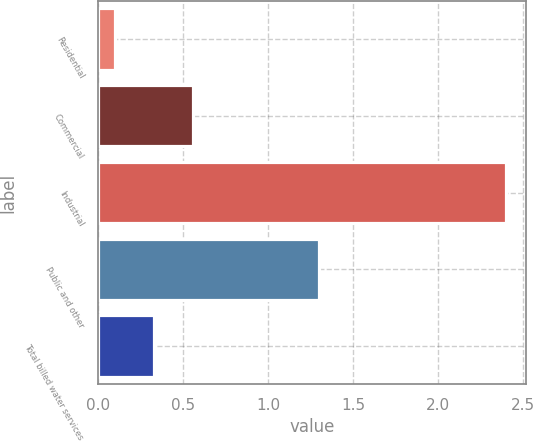<chart> <loc_0><loc_0><loc_500><loc_500><bar_chart><fcel>Residential<fcel>Commercial<fcel>Industrial<fcel>Public and other<fcel>Total billed water services<nl><fcel>0.1<fcel>0.56<fcel>2.4<fcel>1.3<fcel>0.33<nl></chart> 